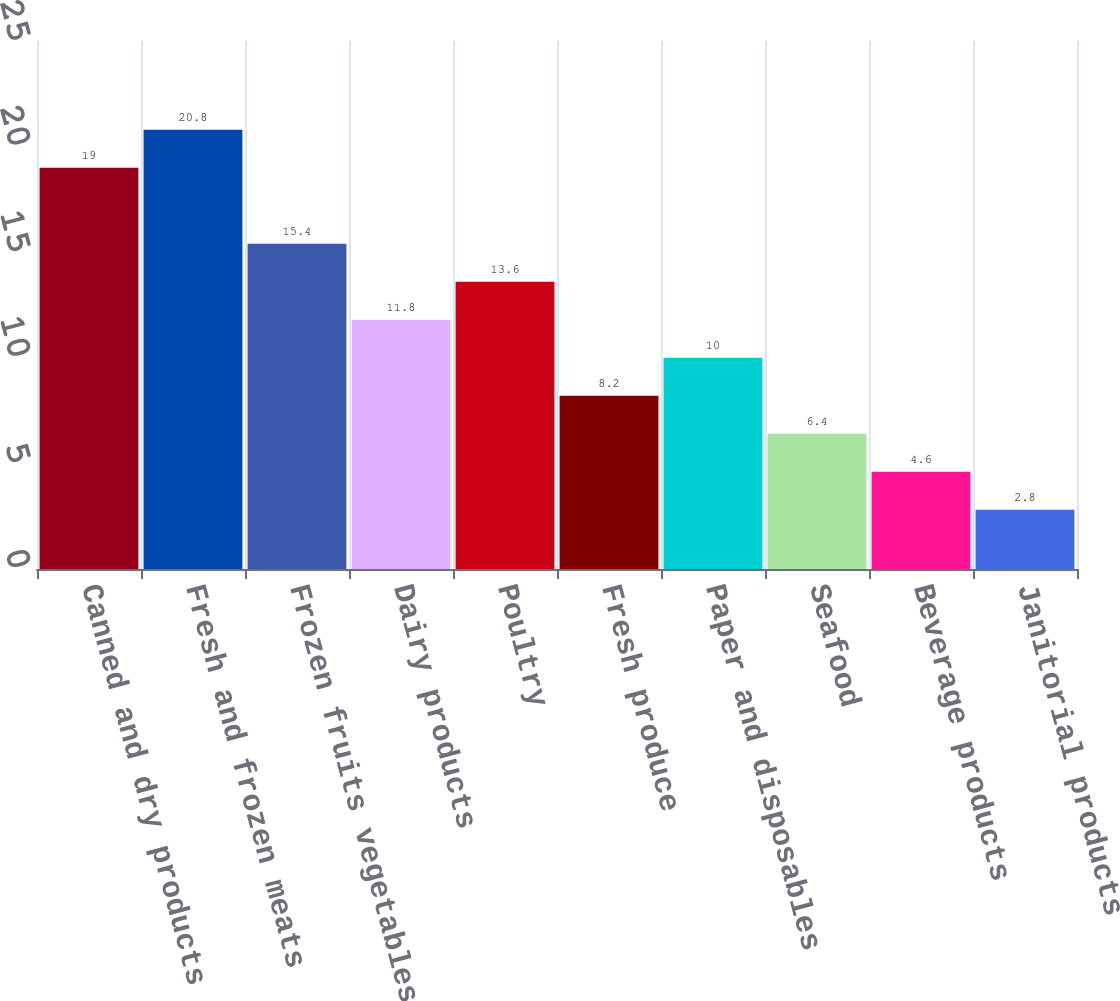<chart> <loc_0><loc_0><loc_500><loc_500><bar_chart><fcel>Canned and dry products<fcel>Fresh and frozen meats<fcel>Frozen fruits vegetables<fcel>Dairy products<fcel>Poultry<fcel>Fresh produce<fcel>Paper and disposables<fcel>Seafood<fcel>Beverage products<fcel>Janitorial products<nl><fcel>19<fcel>20.8<fcel>15.4<fcel>11.8<fcel>13.6<fcel>8.2<fcel>10<fcel>6.4<fcel>4.6<fcel>2.8<nl></chart> 